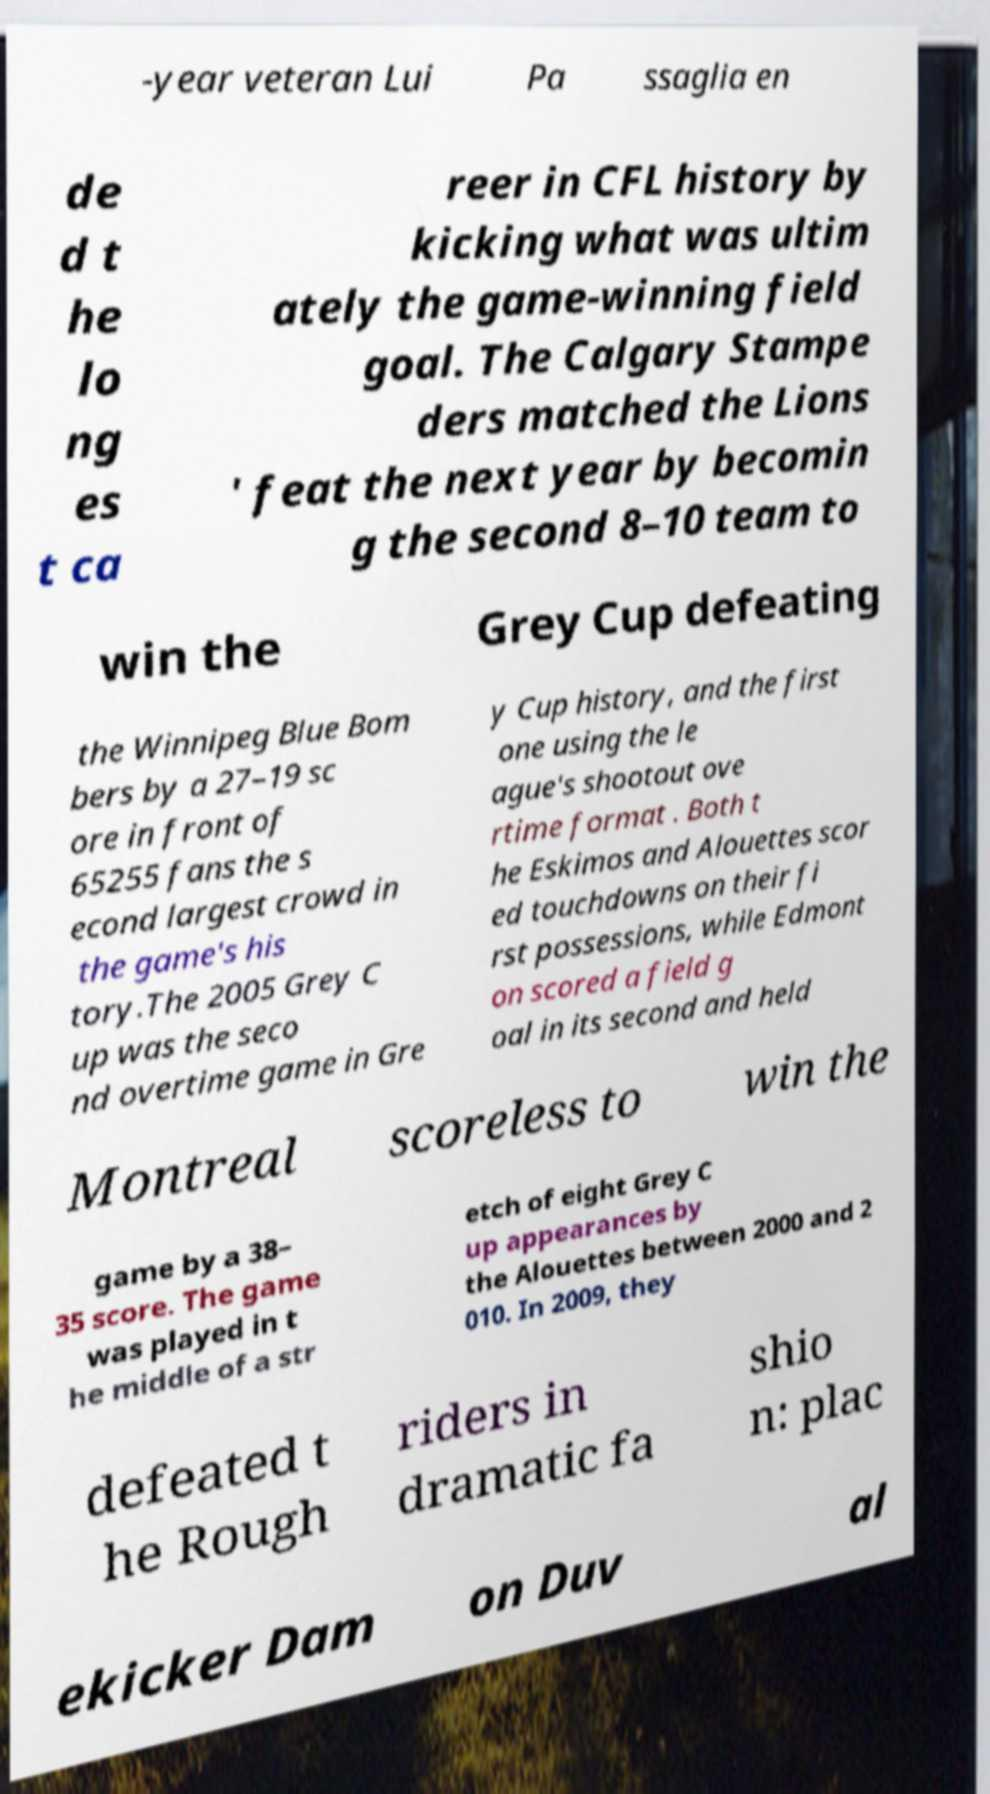Can you read and provide the text displayed in the image?This photo seems to have some interesting text. Can you extract and type it out for me? -year veteran Lui Pa ssaglia en de d t he lo ng es t ca reer in CFL history by kicking what was ultim ately the game-winning field goal. The Calgary Stampe ders matched the Lions ' feat the next year by becomin g the second 8–10 team to win the Grey Cup defeating the Winnipeg Blue Bom bers by a 27–19 sc ore in front of 65255 fans the s econd largest crowd in the game's his tory.The 2005 Grey C up was the seco nd overtime game in Gre y Cup history, and the first one using the le ague's shootout ove rtime format . Both t he Eskimos and Alouettes scor ed touchdowns on their fi rst possessions, while Edmont on scored a field g oal in its second and held Montreal scoreless to win the game by a 38– 35 score. The game was played in t he middle of a str etch of eight Grey C up appearances by the Alouettes between 2000 and 2 010. In 2009, they defeated t he Rough riders in dramatic fa shio n: plac ekicker Dam on Duv al 